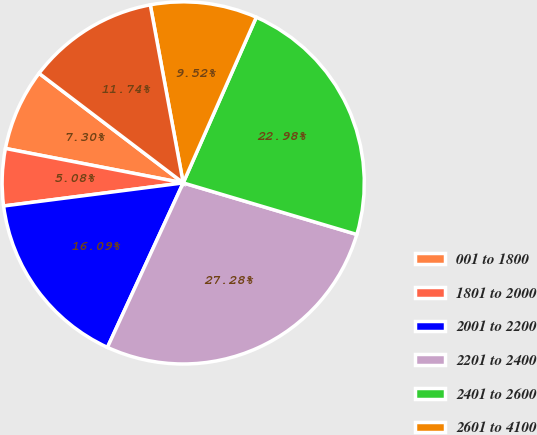<chart> <loc_0><loc_0><loc_500><loc_500><pie_chart><fcel>001 to 1800<fcel>1801 to 2000<fcel>2001 to 2200<fcel>2201 to 2400<fcel>2401 to 2600<fcel>2601 to 4100<fcel>4101 to 5700<nl><fcel>7.3%<fcel>5.08%<fcel>16.09%<fcel>27.27%<fcel>22.98%<fcel>9.52%<fcel>11.74%<nl></chart> 